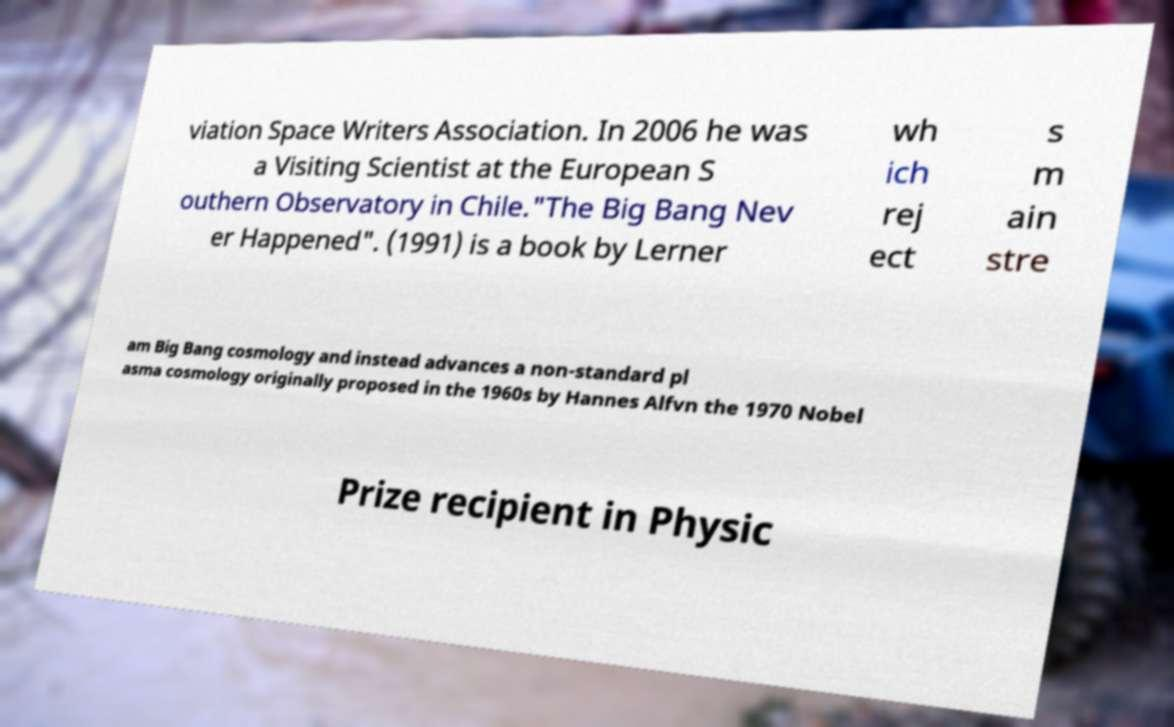Can you accurately transcribe the text from the provided image for me? viation Space Writers Association. In 2006 he was a Visiting Scientist at the European S outhern Observatory in Chile."The Big Bang Nev er Happened". (1991) is a book by Lerner wh ich rej ect s m ain stre am Big Bang cosmology and instead advances a non-standard pl asma cosmology originally proposed in the 1960s by Hannes Alfvn the 1970 Nobel Prize recipient in Physic 